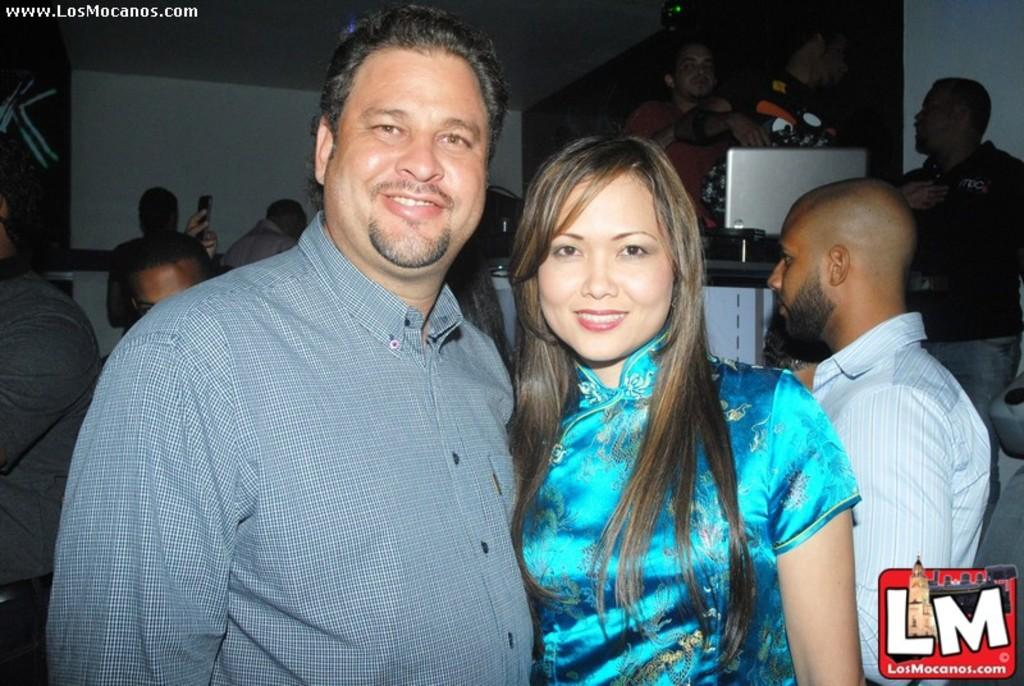What can be seen in the image? There are people standing in the image. How many people are visible in the image? The number of people cannot be determined from the provided fact, but there are at least one or more people present. What might the people be doing in the image? The specific activity of the people cannot be determined from the provided fact, but they are standing. What color is the baby's gold elbow in the image? There is no baby or gold elbow present in the image, as the provided fact only states that there are people standing. 